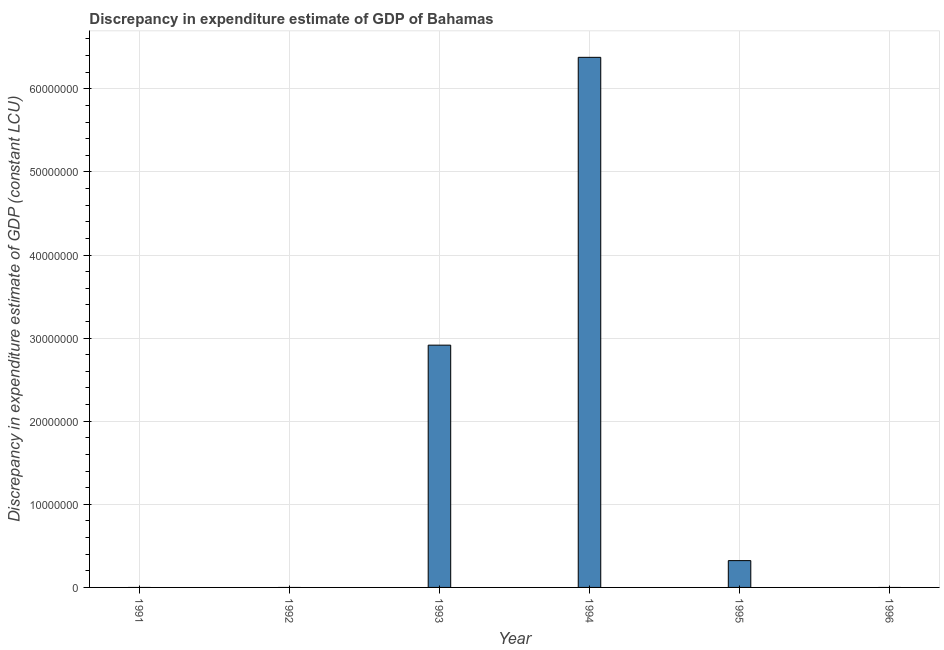Does the graph contain any zero values?
Give a very brief answer. Yes. What is the title of the graph?
Your answer should be very brief. Discrepancy in expenditure estimate of GDP of Bahamas. What is the label or title of the Y-axis?
Provide a short and direct response. Discrepancy in expenditure estimate of GDP (constant LCU). What is the discrepancy in expenditure estimate of gdp in 1993?
Your response must be concise. 2.92e+07. Across all years, what is the maximum discrepancy in expenditure estimate of gdp?
Your answer should be compact. 6.38e+07. Across all years, what is the minimum discrepancy in expenditure estimate of gdp?
Your answer should be compact. 0. What is the sum of the discrepancy in expenditure estimate of gdp?
Offer a terse response. 9.62e+07. What is the difference between the discrepancy in expenditure estimate of gdp in 1993 and 1994?
Provide a short and direct response. -3.46e+07. What is the average discrepancy in expenditure estimate of gdp per year?
Make the answer very short. 1.60e+07. What is the median discrepancy in expenditure estimate of gdp?
Keep it short and to the point. 1.61e+06. In how many years, is the discrepancy in expenditure estimate of gdp greater than 64000000 LCU?
Your answer should be compact. 0. What is the ratio of the discrepancy in expenditure estimate of gdp in 1994 to that in 1995?
Your answer should be very brief. 19.78. What is the difference between the highest and the second highest discrepancy in expenditure estimate of gdp?
Offer a very short reply. 3.46e+07. What is the difference between the highest and the lowest discrepancy in expenditure estimate of gdp?
Your answer should be very brief. 6.38e+07. In how many years, is the discrepancy in expenditure estimate of gdp greater than the average discrepancy in expenditure estimate of gdp taken over all years?
Make the answer very short. 2. Are all the bars in the graph horizontal?
Ensure brevity in your answer.  No. How many years are there in the graph?
Your answer should be very brief. 6. What is the difference between two consecutive major ticks on the Y-axis?
Your answer should be very brief. 1.00e+07. Are the values on the major ticks of Y-axis written in scientific E-notation?
Offer a very short reply. No. What is the Discrepancy in expenditure estimate of GDP (constant LCU) in 1991?
Offer a terse response. 0. What is the Discrepancy in expenditure estimate of GDP (constant LCU) of 1992?
Ensure brevity in your answer.  0. What is the Discrepancy in expenditure estimate of GDP (constant LCU) in 1993?
Provide a short and direct response. 2.92e+07. What is the Discrepancy in expenditure estimate of GDP (constant LCU) of 1994?
Your answer should be compact. 6.38e+07. What is the Discrepancy in expenditure estimate of GDP (constant LCU) in 1995?
Offer a very short reply. 3.23e+06. What is the Discrepancy in expenditure estimate of GDP (constant LCU) of 1996?
Offer a very short reply. 0. What is the difference between the Discrepancy in expenditure estimate of GDP (constant LCU) in 1993 and 1994?
Offer a terse response. -3.46e+07. What is the difference between the Discrepancy in expenditure estimate of GDP (constant LCU) in 1993 and 1995?
Keep it short and to the point. 2.59e+07. What is the difference between the Discrepancy in expenditure estimate of GDP (constant LCU) in 1994 and 1995?
Offer a terse response. 6.06e+07. What is the ratio of the Discrepancy in expenditure estimate of GDP (constant LCU) in 1993 to that in 1994?
Your response must be concise. 0.46. What is the ratio of the Discrepancy in expenditure estimate of GDP (constant LCU) in 1993 to that in 1995?
Your answer should be compact. 9.04. What is the ratio of the Discrepancy in expenditure estimate of GDP (constant LCU) in 1994 to that in 1995?
Give a very brief answer. 19.78. 